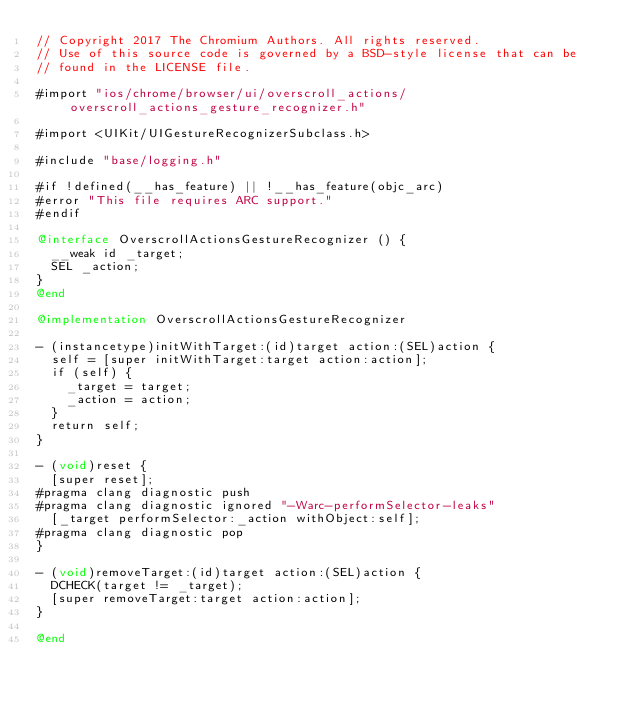Convert code to text. <code><loc_0><loc_0><loc_500><loc_500><_ObjectiveC_>// Copyright 2017 The Chromium Authors. All rights reserved.
// Use of this source code is governed by a BSD-style license that can be
// found in the LICENSE file.

#import "ios/chrome/browser/ui/overscroll_actions/overscroll_actions_gesture_recognizer.h"

#import <UIKit/UIGestureRecognizerSubclass.h>

#include "base/logging.h"

#if !defined(__has_feature) || !__has_feature(objc_arc)
#error "This file requires ARC support."
#endif

@interface OverscrollActionsGestureRecognizer () {
  __weak id _target;
  SEL _action;
}
@end

@implementation OverscrollActionsGestureRecognizer

- (instancetype)initWithTarget:(id)target action:(SEL)action {
  self = [super initWithTarget:target action:action];
  if (self) {
    _target = target;
    _action = action;
  }
  return self;
}

- (void)reset {
  [super reset];
#pragma clang diagnostic push
#pragma clang diagnostic ignored "-Warc-performSelector-leaks"
  [_target performSelector:_action withObject:self];
#pragma clang diagnostic pop
}

- (void)removeTarget:(id)target action:(SEL)action {
  DCHECK(target != _target);
  [super removeTarget:target action:action];
}

@end
</code> 